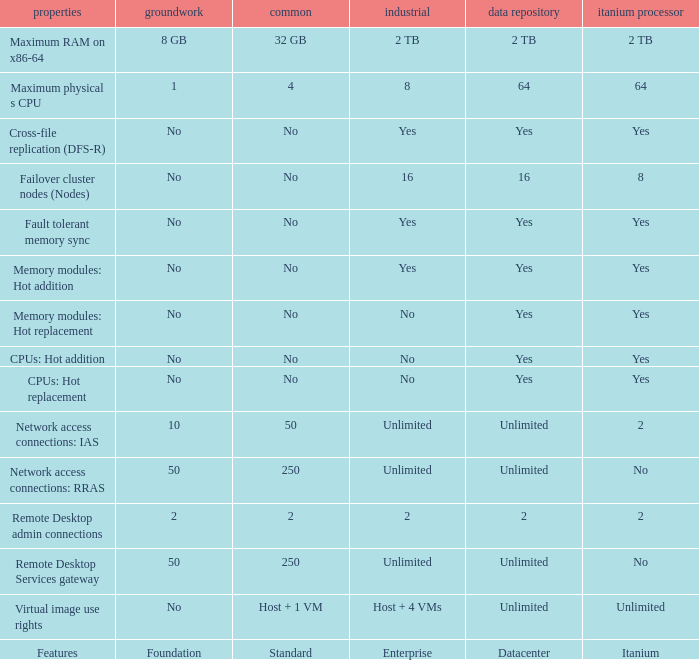What are the features that have "yes" mentioned in the datacenter column? Cross-file replication (DFS-R), Fault tolerant memory sync, Memory modules: Hot addition, Memory modules: Hot replacement, CPUs: Hot addition, CPUs: Hot replacement. 